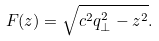Convert formula to latex. <formula><loc_0><loc_0><loc_500><loc_500>F ( z ) = \sqrt { c ^ { 2 } q _ { \perp } ^ { 2 } - z ^ { 2 } } .</formula> 